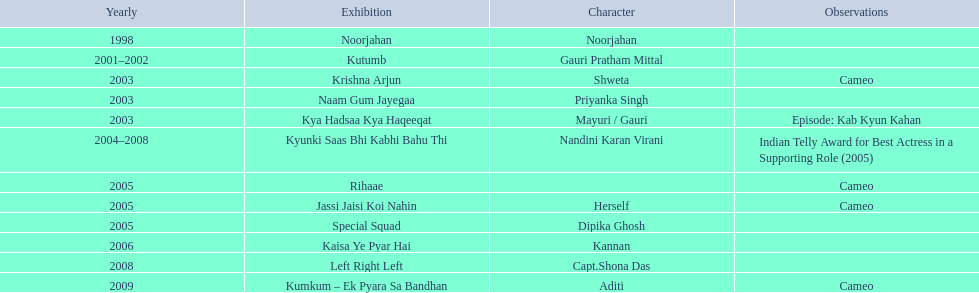How many shows are there? Noorjahan, Kutumb, Krishna Arjun, Naam Gum Jayegaa, Kya Hadsaa Kya Haqeeqat, Kyunki Saas Bhi Kabhi Bahu Thi, Rihaae, Jassi Jaisi Koi Nahin, Special Squad, Kaisa Ye Pyar Hai, Left Right Left, Kumkum – Ek Pyara Sa Bandhan. How many shows did she make a cameo appearance? Krishna Arjun, Rihaae, Jassi Jaisi Koi Nahin, Kumkum – Ek Pyara Sa Bandhan. Of those, how many did she play herself? Jassi Jaisi Koi Nahin. 